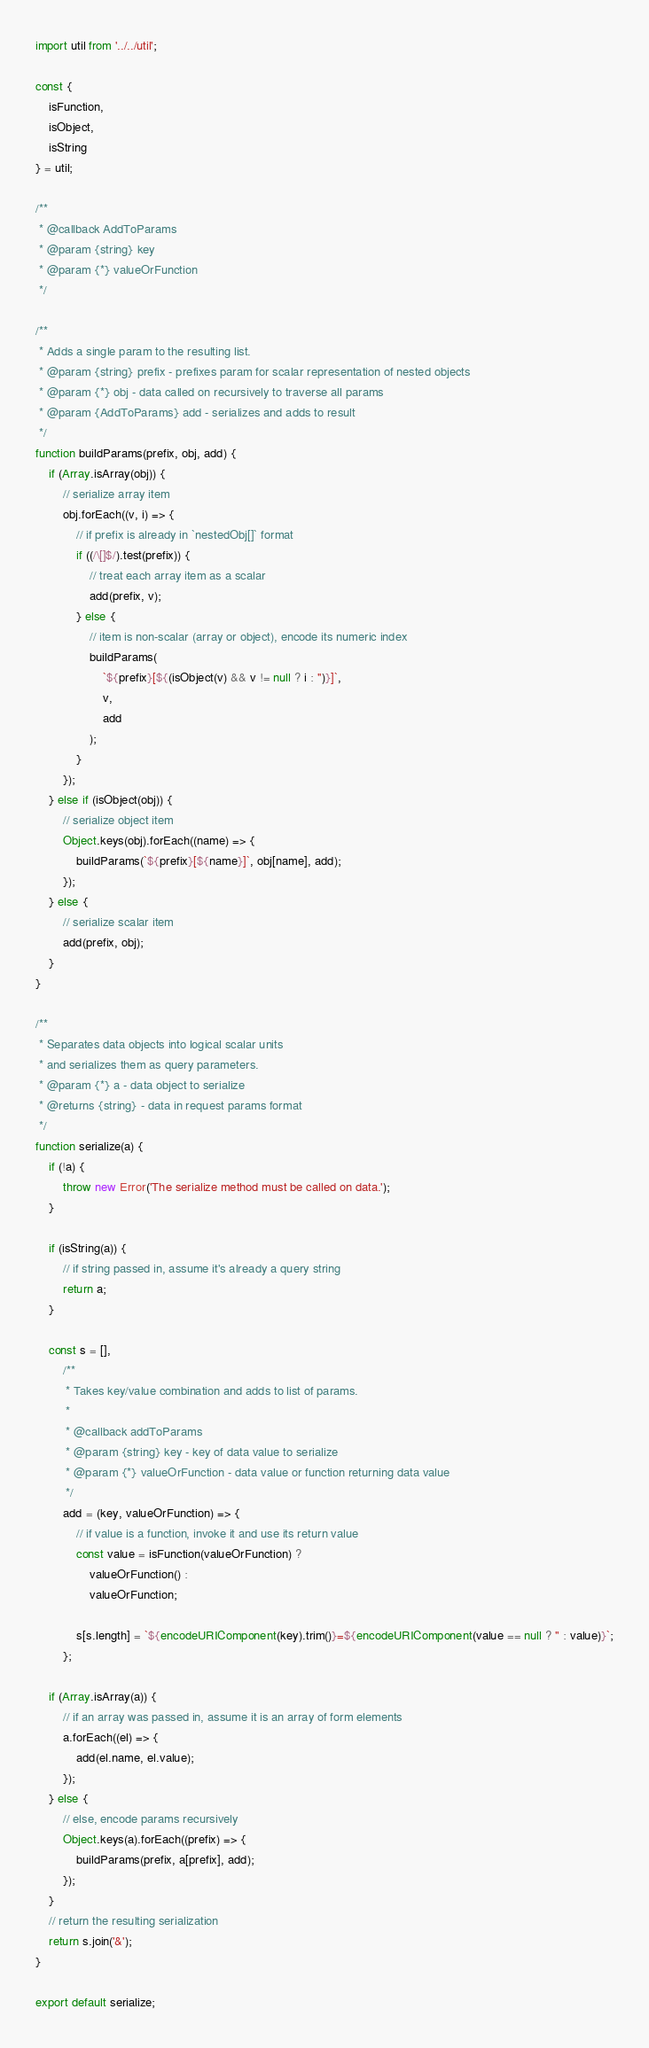Convert code to text. <code><loc_0><loc_0><loc_500><loc_500><_JavaScript_>import util from '../../util';

const {
    isFunction,
    isObject,
    isString
} = util;

/**
 * @callback AddToParams
 * @param {string} key
 * @param {*} valueOrFunction
 */

/**
 * Adds a single param to the resulting list.
 * @param {string} prefix - prefixes param for scalar representation of nested objects
 * @param {*} obj - data called on recursively to traverse all params
 * @param {AddToParams} add - serializes and adds to result
 */
function buildParams(prefix, obj, add) {
    if (Array.isArray(obj)) {
        // serialize array item
        obj.forEach((v, i) => {
            // if prefix is already in `nestedObj[]` format
            if ((/\[]$/).test(prefix)) {
                // treat each array item as a scalar
                add(prefix, v);
            } else {
                // item is non-scalar (array or object), encode its numeric index
                buildParams(
                    `${prefix}[${(isObject(v) && v != null ? i : '')}]`,
                    v,
                    add
                );
            }
        });
    } else if (isObject(obj)) {
        // serialize object item
        Object.keys(obj).forEach((name) => {
            buildParams(`${prefix}[${name}]`, obj[name], add);
        });
    } else {
        // serialize scalar item
        add(prefix, obj);
    }
}

/**
 * Separates data objects into logical scalar units
 * and serializes them as query parameters.
 * @param {*} a - data object to serialize
 * @returns {string} - data in request params format
 */
function serialize(a) {
    if (!a) {
        throw new Error('The serialize method must be called on data.');
    }

    if (isString(a)) {
        // if string passed in, assume it's already a query string
        return a;
    }

    const s = [],
        /**
         * Takes key/value combination and adds to list of params.
         *
         * @callback addToParams
         * @param {string} key - key of data value to serialize
         * @param {*} valueOrFunction - data value or function returning data value
         */
        add = (key, valueOrFunction) => {
            // if value is a function, invoke it and use its return value
            const value = isFunction(valueOrFunction) ?
                valueOrFunction() :
                valueOrFunction;

            s[s.length] = `${encodeURIComponent(key).trim()}=${encodeURIComponent(value == null ? '' : value)}`;
        };

    if (Array.isArray(a)) {
        // if an array was passed in, assume it is an array of form elements
        a.forEach((el) => {
            add(el.name, el.value);
        });
    } else {
        // else, encode params recursively
        Object.keys(a).forEach((prefix) => {
            buildParams(prefix, a[prefix], add);
        });
    }
    // return the resulting serialization
    return s.join('&');
}

export default serialize;
</code> 